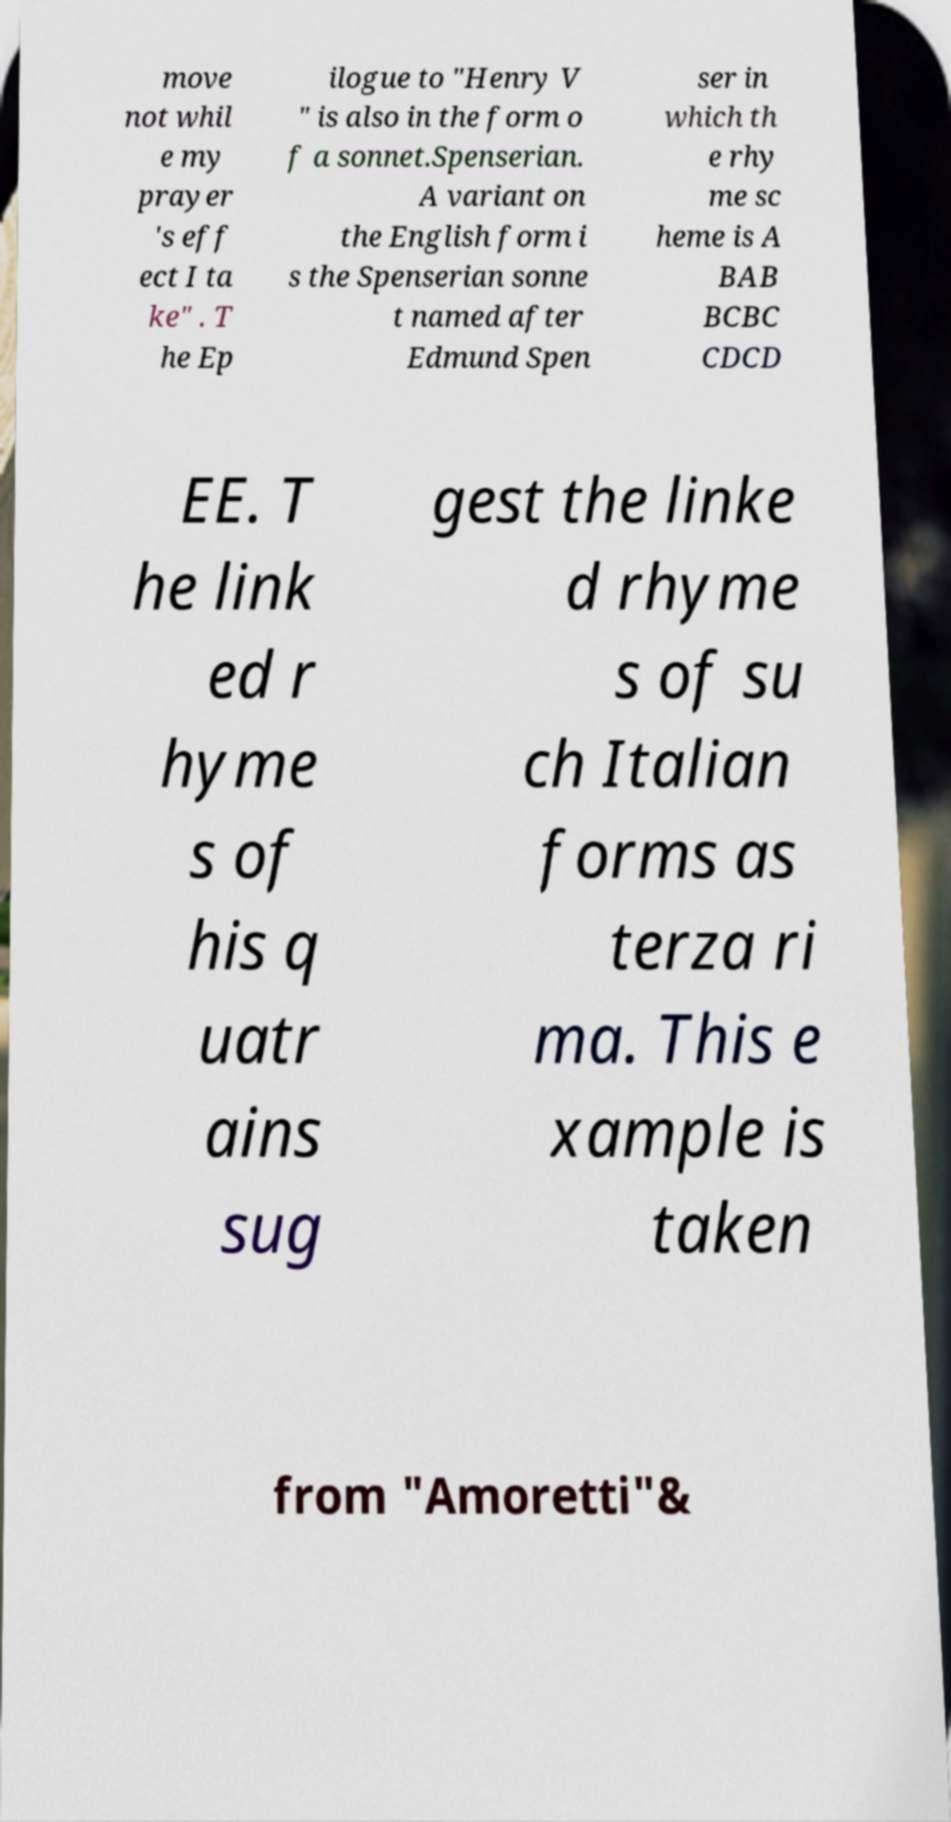I need the written content from this picture converted into text. Can you do that? move not whil e my prayer 's eff ect I ta ke" . T he Ep ilogue to "Henry V " is also in the form o f a sonnet.Spenserian. A variant on the English form i s the Spenserian sonne t named after Edmund Spen ser in which th e rhy me sc heme is A BAB BCBC CDCD EE. T he link ed r hyme s of his q uatr ains sug gest the linke d rhyme s of su ch Italian forms as terza ri ma. This e xample is taken from "Amoretti"& 